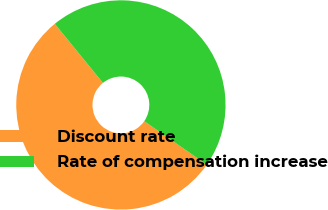<chart> <loc_0><loc_0><loc_500><loc_500><pie_chart><fcel>Discount rate<fcel>Rate of compensation increase<nl><fcel>54.44%<fcel>45.56%<nl></chart> 